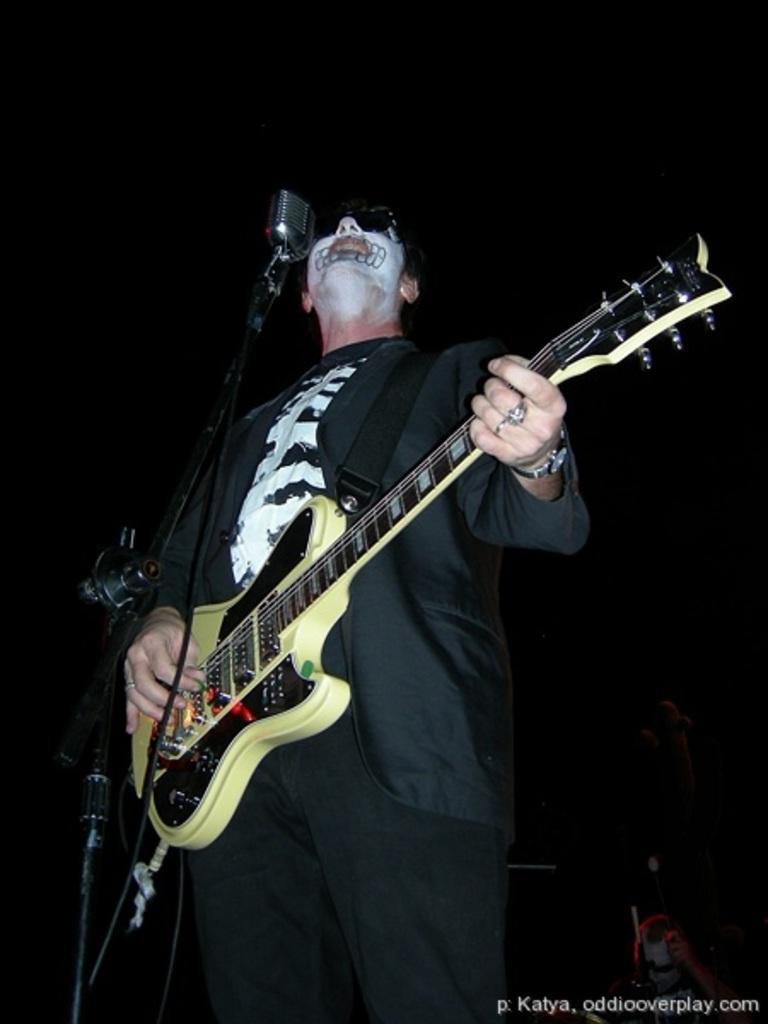Could you give a brief overview of what you see in this image? In the center of the image we can see a man standing and playing a guitar, before him there is a mic. We can see a face painting on his face. 